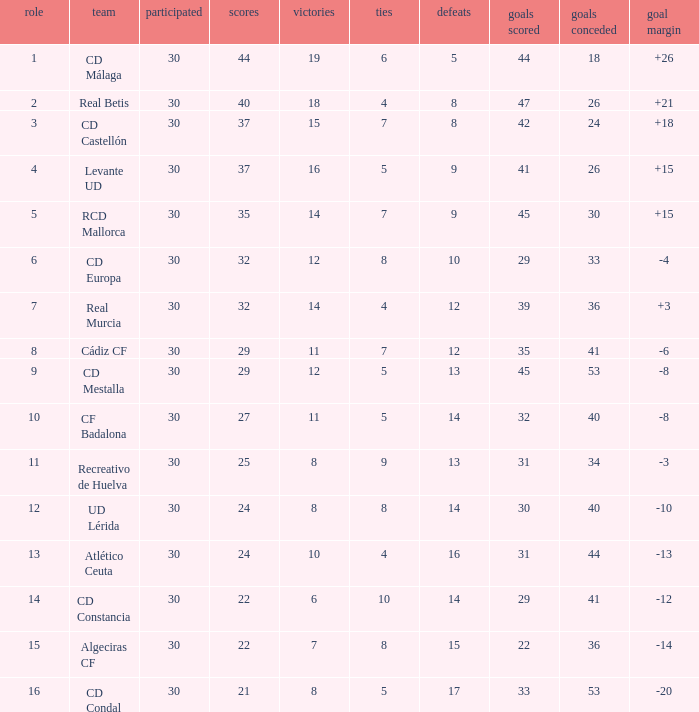What is the number of draws when played is smaller than 30? 0.0. 